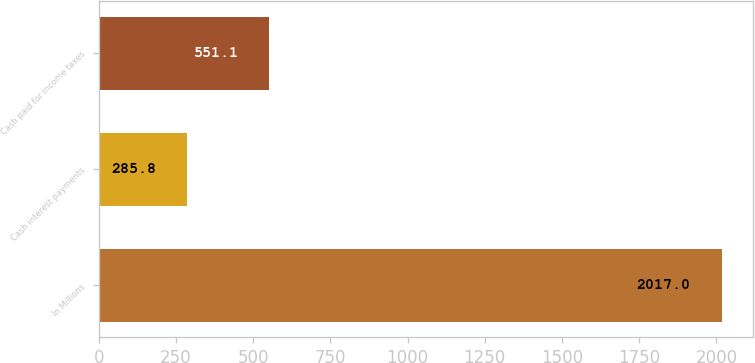Convert chart. <chart><loc_0><loc_0><loc_500><loc_500><bar_chart><fcel>In Millions<fcel>Cash interest payments<fcel>Cash paid for income taxes<nl><fcel>2017<fcel>285.8<fcel>551.1<nl></chart> 